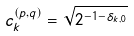Convert formula to latex. <formula><loc_0><loc_0><loc_500><loc_500>c ^ { ( p , q ) } _ { k } = \sqrt { 2 ^ { - 1 - \delta _ { k , 0 } } }</formula> 